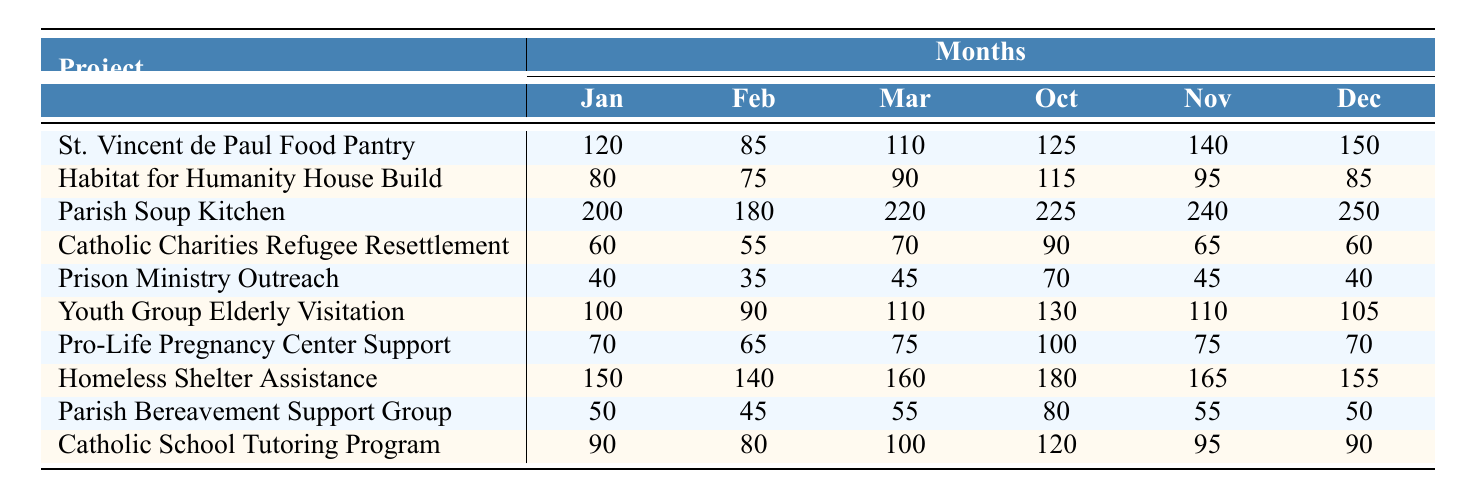How many volunteer hours were contributed to the Parish Soup Kitchen in March? According to the table, the value for March under the Parish Soup Kitchen is listed as 220 hours.
Answer: 220 What is the total number of volunteer hours for the St. Vincent de Paul Food Pantry across all months? To find the total, we sum the hours: 120 + 85 + 110 + 95 + 105 + 130 + 100 + 115 + 90 + 125 + 140 + 150 = 1,405 hours.
Answer: 1,405 Which project had the highest number of volunteer hours in December? In December, we compare the last column of all projects. The highest value is 250 hours for the Parish Soup Kitchen.
Answer: Parish Soup Kitchen Did the Prison Ministry Outreach contribute more volunteer hours in October than in November? The October contribution is 70 hours, while in November it was 45 hours. Since 70 is greater than 45, the statement is true.
Answer: Yes What is the average number of volunteer hours for the Youth Group Elderly Visitation? We sum the hours: 100 + 90 + 110 + 105 + 115 + 120 + 95 + 85 + 125 + 130 + 110 + 105 = 1,385. There are 12 months, so the average is 1,385/12 = approximately 115.42 hours.
Answer: 115.42 Which project saw the least amount of volunteer hours in April? For April, we compare the contributions of each project: 95 (St. Vincent), 100 (Habitat), 190 (Parish Soup), 65 (Charities), 50 (Prison), 105 (Youth), 80 (Pregnancy), 145 (Homeless), 60 (Bereavement), 120 (Tutoring). The least is 50 hours for Prison Ministry Outreach.
Answer: Prison Ministry Outreach What is the difference in volunteer hours contributed in January between the Homeless Shelter Assistance and the Catholic School Tutoring Program? In January, Homeless Shelter Assistance contributed 150 hours, while the Catholic School Tutoring Program contributed 90 hours. The difference is 150 - 90 = 60 hours.
Answer: 60 If the total hours for all projects in November is X, what is X? Summing the hours for each project in November gives us: 140 (St. Vincent) + 95 (Habitat) + 240 (Parish Soup) + 65 (Charities) + 45 (Prison) + 110 (Youth) + 75 (Pregnancy) + 165 (Homeless) + 55 (Bereavement) + 95 (Tutoring) = 1,210 hours.
Answer: 1,210 How many projects contributed more than 100 hours in June? The following projects from June had over 100 hours: Parish Soup Kitchen (230), Youth Group Elderly Visitation (120), Homeless Shelter Assistance (170). So, there are 3 projects.
Answer: 3 Was the total contribution for the Catholic Charities Refugee Resettlement higher in March than in May? The March contribution is 70 hours, while in May it is 75 hours. Since 70 is less than 75, the statement is false.
Answer: No 